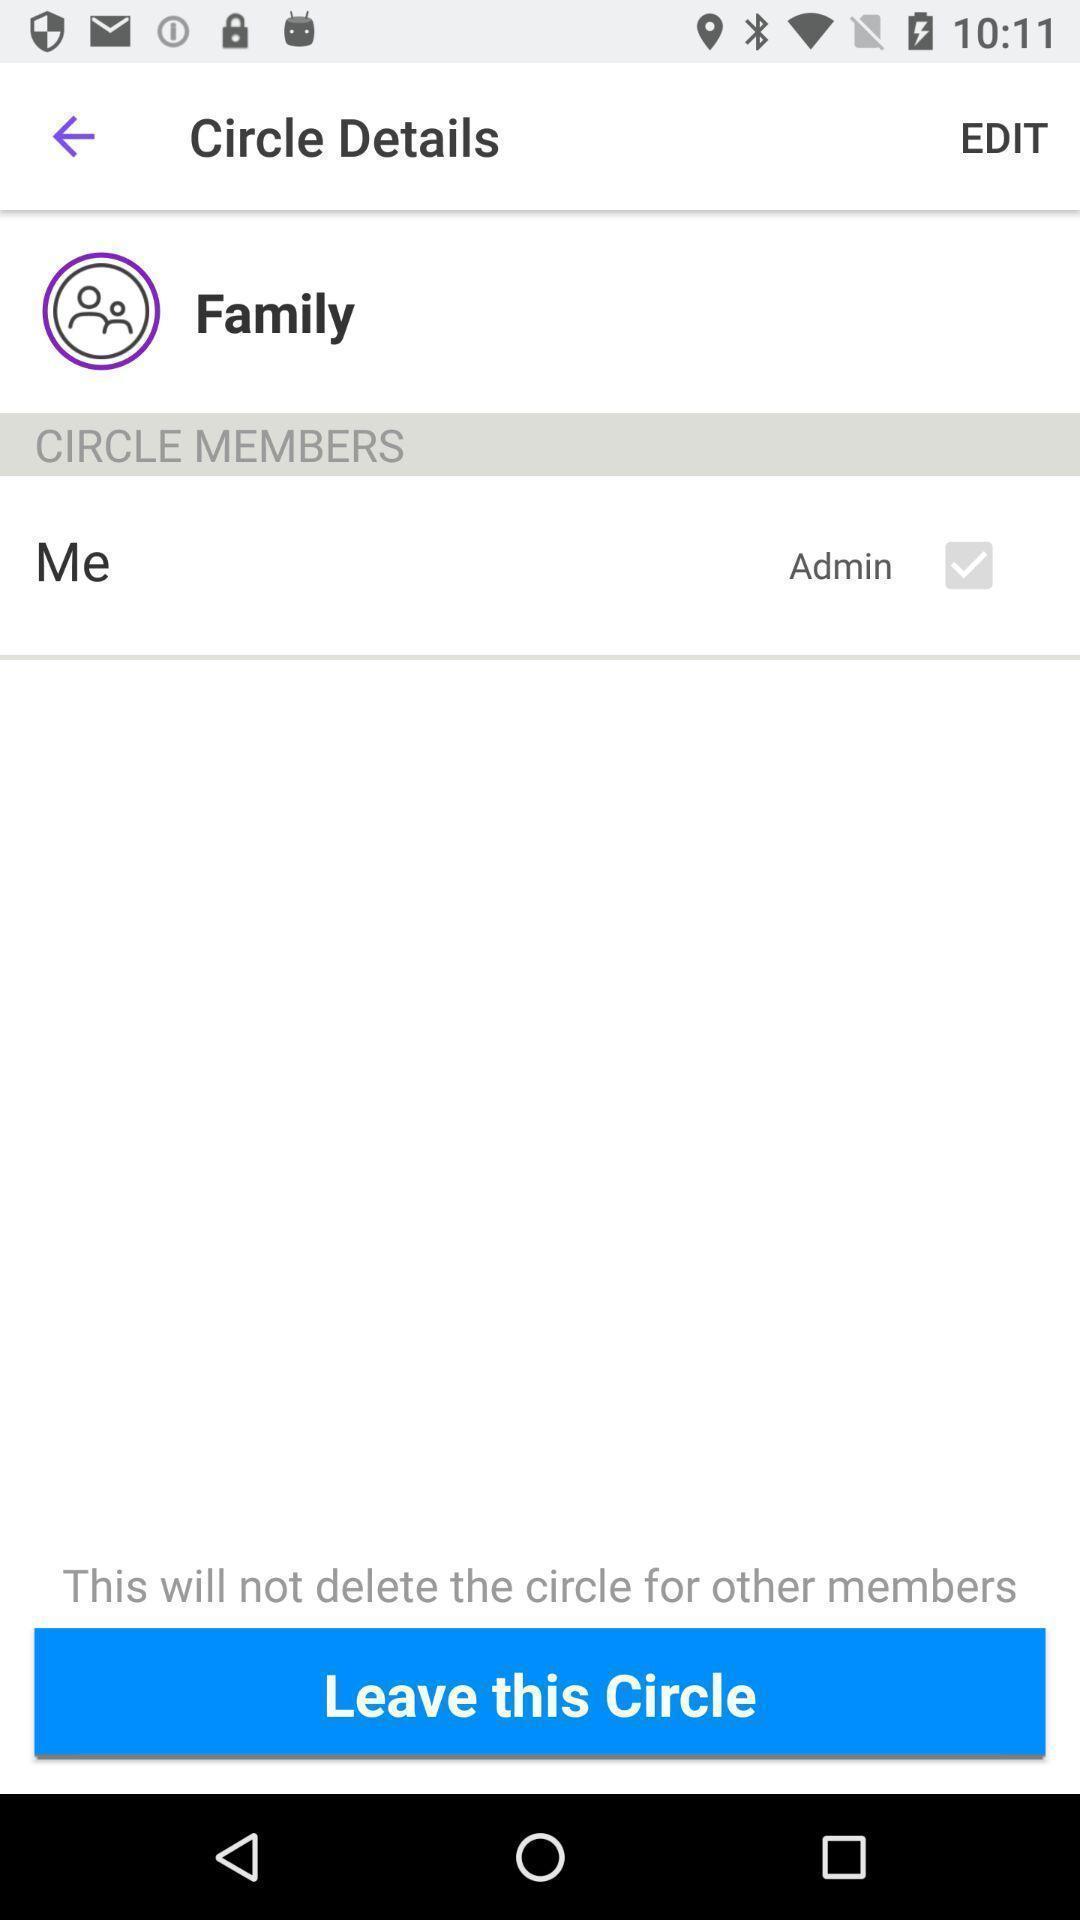Tell me what you see in this picture. Page showing different options on an app. 